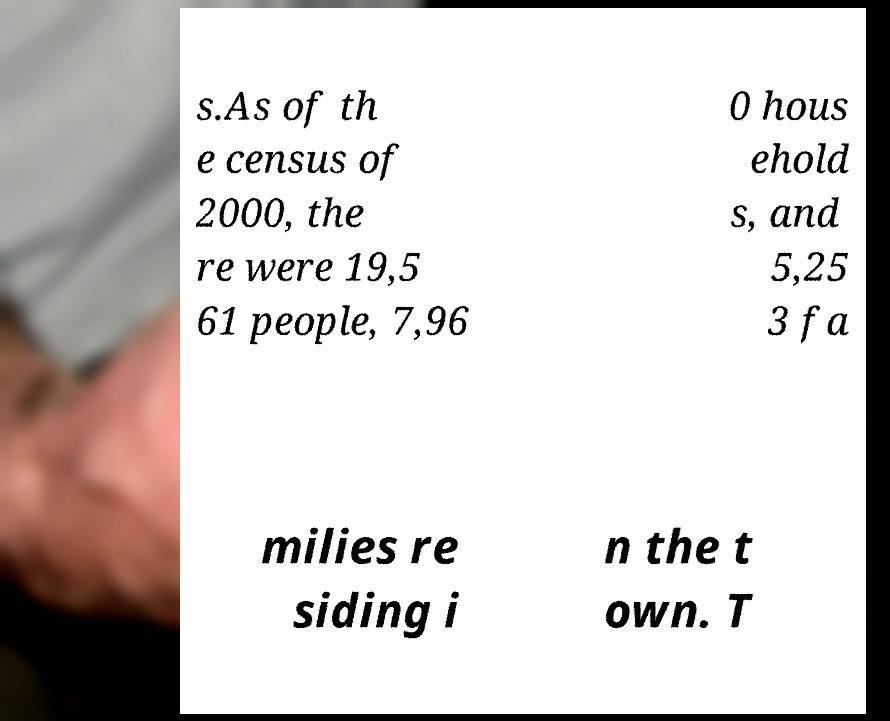For documentation purposes, I need the text within this image transcribed. Could you provide that? s.As of th e census of 2000, the re were 19,5 61 people, 7,96 0 hous ehold s, and 5,25 3 fa milies re siding i n the t own. T 